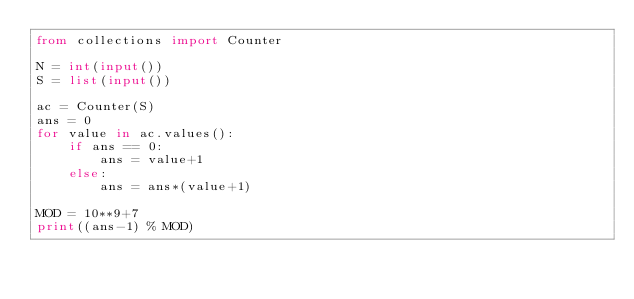<code> <loc_0><loc_0><loc_500><loc_500><_Python_>from collections import Counter

N = int(input())
S = list(input())

ac = Counter(S)
ans = 0
for value in ac.values():
    if ans == 0:
        ans = value+1
    else:
        ans = ans*(value+1)

MOD = 10**9+7
print((ans-1) % MOD)
</code> 